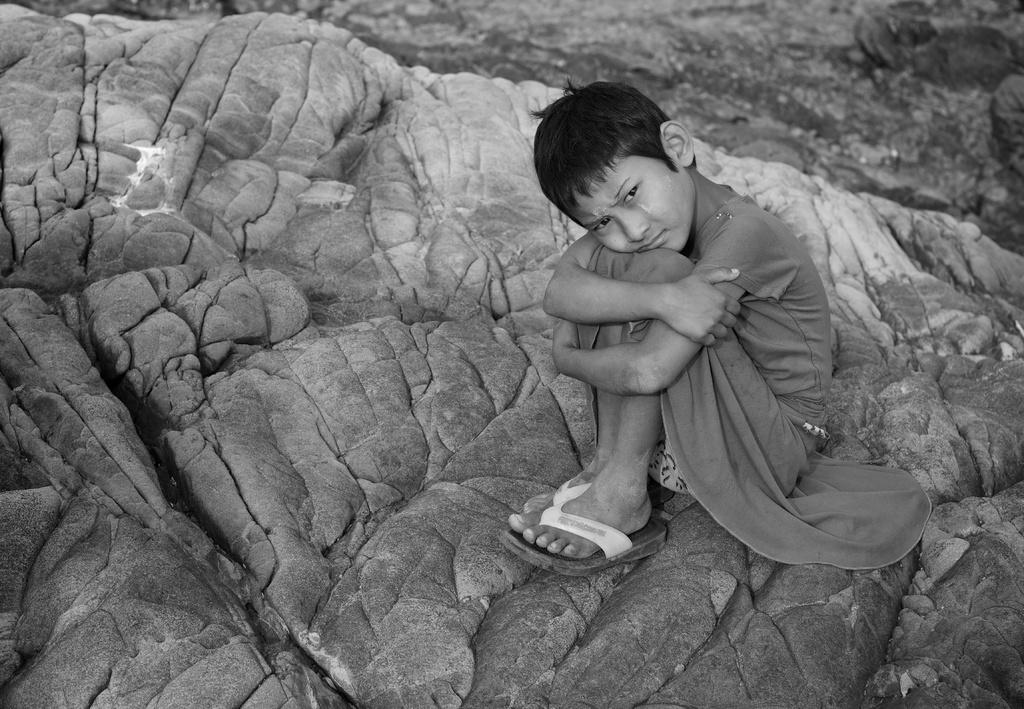What is the main subject of the image? The main subject of the image is a kid. Where is the kid located in the image? The kid is sitting on a rock. What type of steel is used to construct the scissors in the image? There are no scissors present in the image, so it is not possible to determine the type of steel used. 